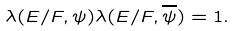<formula> <loc_0><loc_0><loc_500><loc_500>\lambda ( E / F , \psi ) \lambda ( E / F , \overline { \psi } ) = 1 .</formula> 